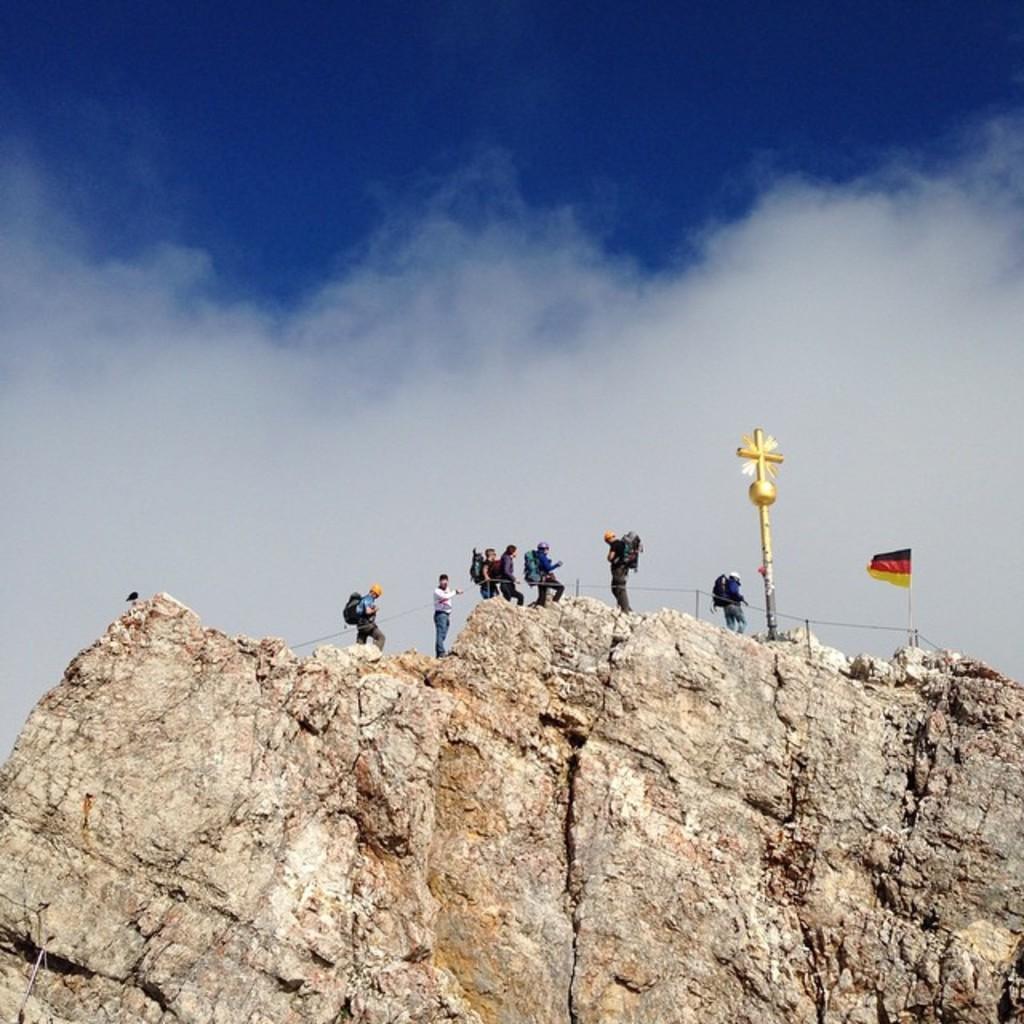Could you give a brief overview of what you see in this image? At the bottom of this image, there is a mountain, on which there is a flag, a cross, a fence and persons. In the background, there are clouds in the sky. 